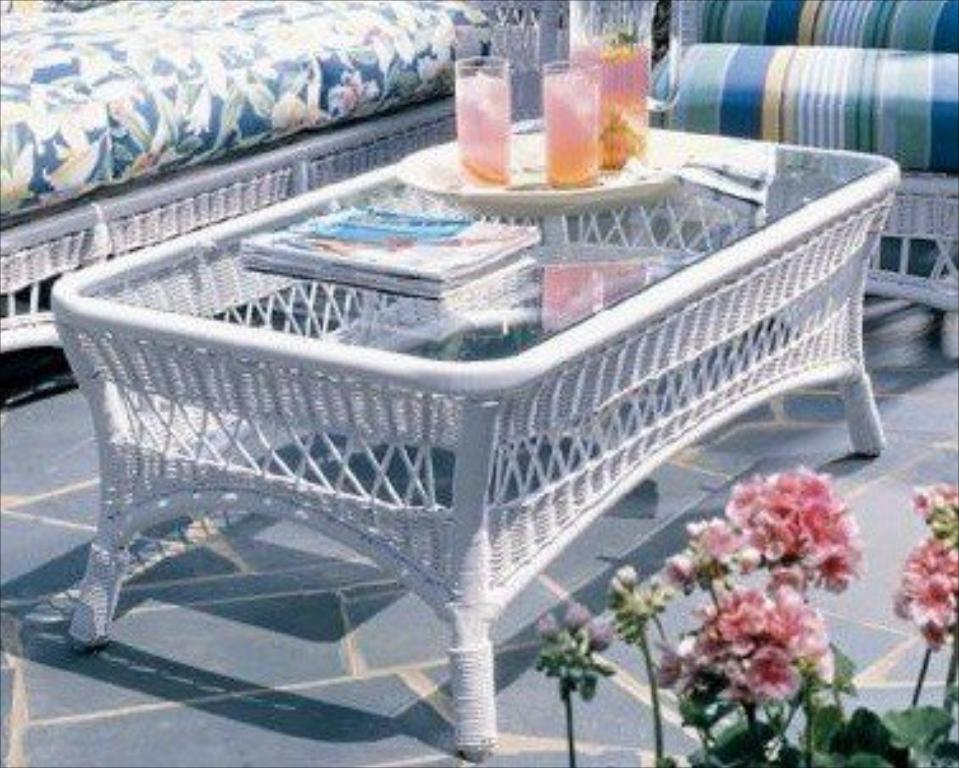What type of furniture is in the image? There is a sofa set in the image. What can be seen on the serving plate? Glass tumblers are present on a serving plate. What is the purpose of the jug in the image? The jug is likely used for holding a beverage. What type of items are on the side table? There are papers on the side table. What kind of vegetation is visible in the image? Plants with flowers are visible in the image. What type of alley can be seen in the image? There is no alley present in the image. What books are being read by the plants in the image? There are no books or plants reading in the image. 